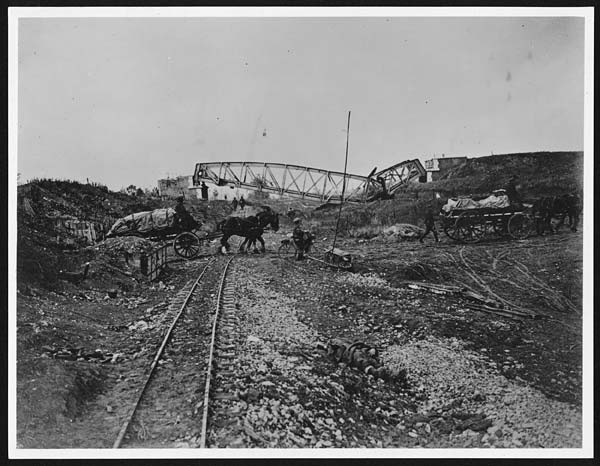What can you tell me about the bridge seen in the image? The bridge in the image appears to be under construction or possibly damaged. It is a large, metal structure spanning what seems to be a ravine or riverbed. The bridge's incomplete state suggests either recent damage or that it is in the process of being built, indicative of the burgeoning railway infrastructure of the late 19th or early 20th century. Describe the daily life of the people working on the railroad depicted in the image. The daily life of the workers building the railroad in the image would have been grueling and monotonous. Their day would start early in the morning, with long hours of physically exhausting manual labor. Tasks might include laying tracks, moving heavy materials, and constructing bridges. Meals would be simple and taken during brief breaks. The workers likely lived in makeshift camps with sparse amenities, facing isolation from their families and minimal medical care. Despite these hardships, there was often a sense of camaraderie among the workers, who shared both the physical challenges and the collective goal of completing the railway. 